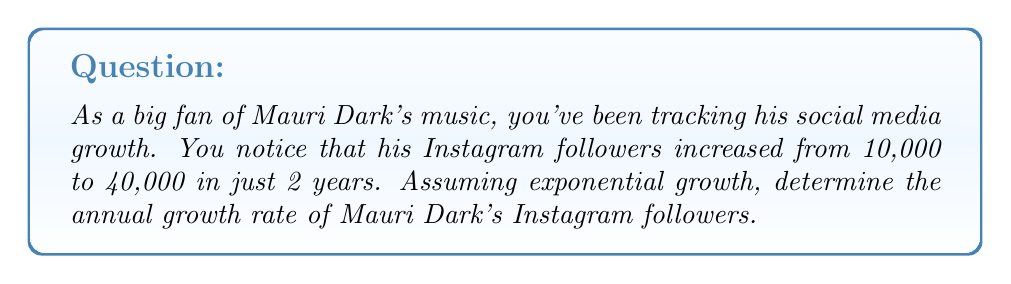Show me your answer to this math problem. Let's approach this step-by-step using the exponential growth formula:

$$A = P(1 + r)^t$$

Where:
$A$ = Final amount
$P$ = Initial amount
$r$ = Annual growth rate (in decimal form)
$t$ = Time in years

We know:
$P = 10,000$ (initial followers)
$A = 40,000$ (final followers)
$t = 2$ years

Let's substitute these values into the formula:

$$40,000 = 10,000(1 + r)^2$$

Simplify:
$$4 = (1 + r)^2$$

Take the square root of both sides:
$$\sqrt{4} = 1 + r$$
$$2 = 1 + r$$

Solve for $r$:
$$r = 2 - 1 = 1$$

Convert to a percentage:
$$r = 1 * 100\% = 100\%$$

Therefore, the annual growth rate is 100%.
Answer: The annual exponential growth rate of Mauri Dark's Instagram followers is 100%. 